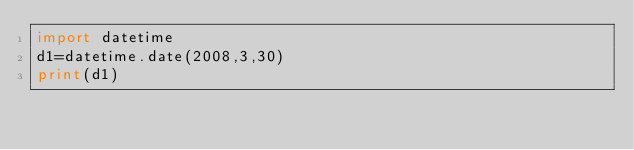Convert code to text. <code><loc_0><loc_0><loc_500><loc_500><_Python_>import datetime
d1=datetime.date(2008,3,30)
print(d1)</code> 